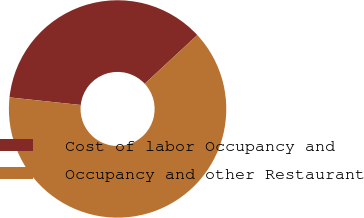Convert chart to OTSL. <chart><loc_0><loc_0><loc_500><loc_500><pie_chart><fcel>Cost of labor Occupancy and<fcel>Occupancy and other Restaurant<nl><fcel>36.41%<fcel>63.59%<nl></chart> 